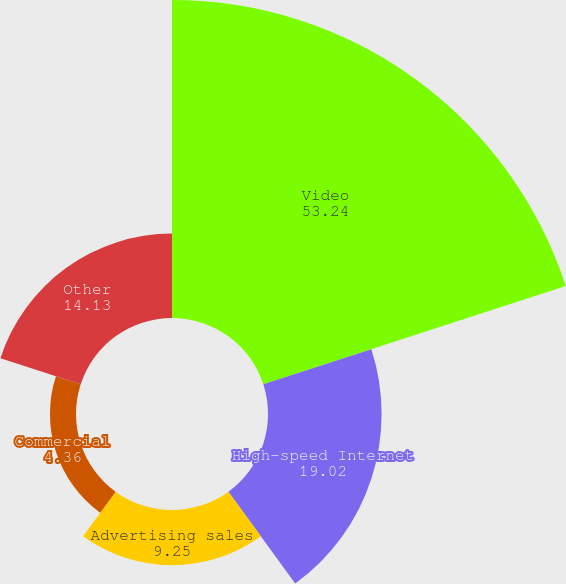Convert chart to OTSL. <chart><loc_0><loc_0><loc_500><loc_500><pie_chart><fcel>Video<fcel>High-speed Internet<fcel>Advertising sales<fcel>Commercial<fcel>Other<nl><fcel>53.24%<fcel>19.02%<fcel>9.25%<fcel>4.36%<fcel>14.13%<nl></chart> 